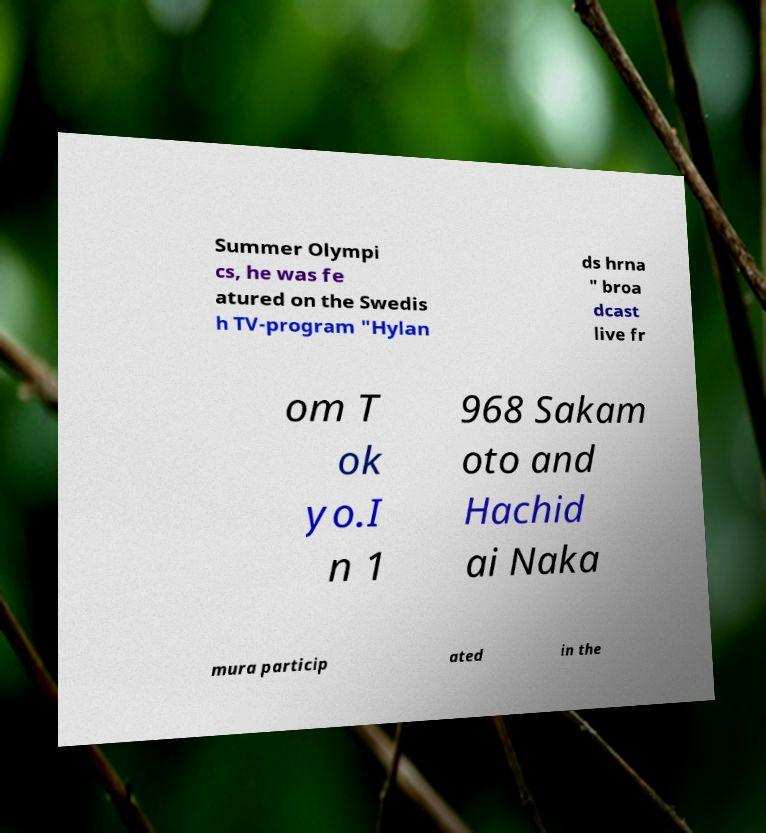Can you read and provide the text displayed in the image?This photo seems to have some interesting text. Can you extract and type it out for me? Summer Olympi cs, he was fe atured on the Swedis h TV-program "Hylan ds hrna " broa dcast live fr om T ok yo.I n 1 968 Sakam oto and Hachid ai Naka mura particip ated in the 